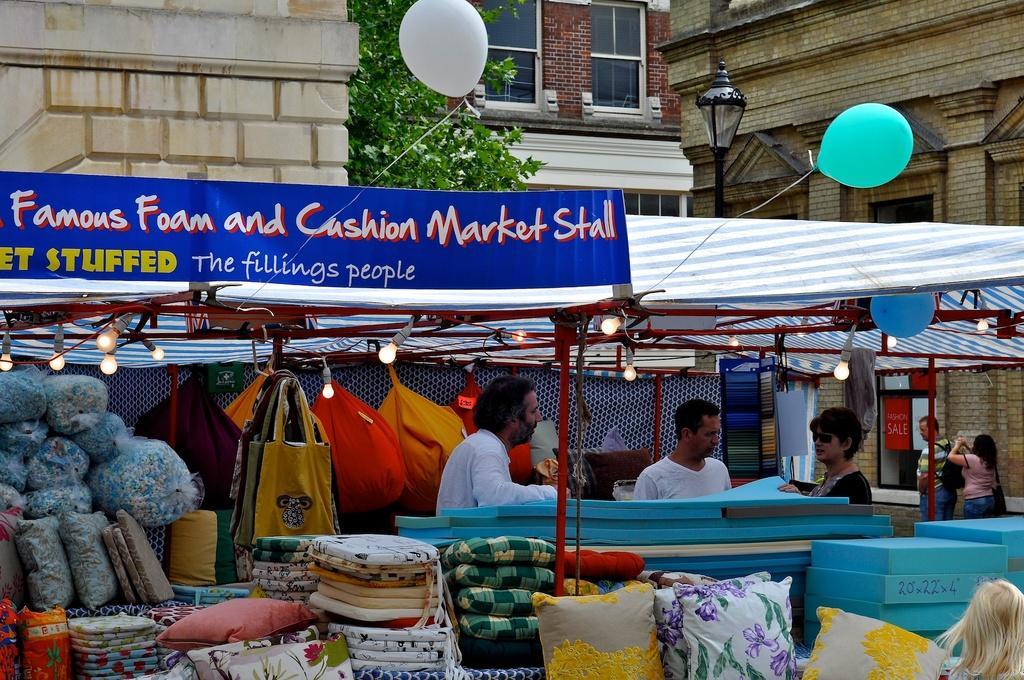Describe this image in one or two sentences. There are stalls and five persons. Here we can see pillows, bags, lights, balloons, clothes, and a board. In the background we can see a pole, tree, and buildings. 